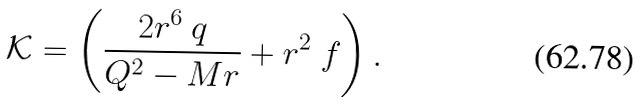<formula> <loc_0><loc_0><loc_500><loc_500>\mathcal { K } = \left ( \frac { 2 r ^ { 6 } \ q } { Q ^ { 2 } - M r } + r ^ { 2 } \ f \right ) .</formula> 